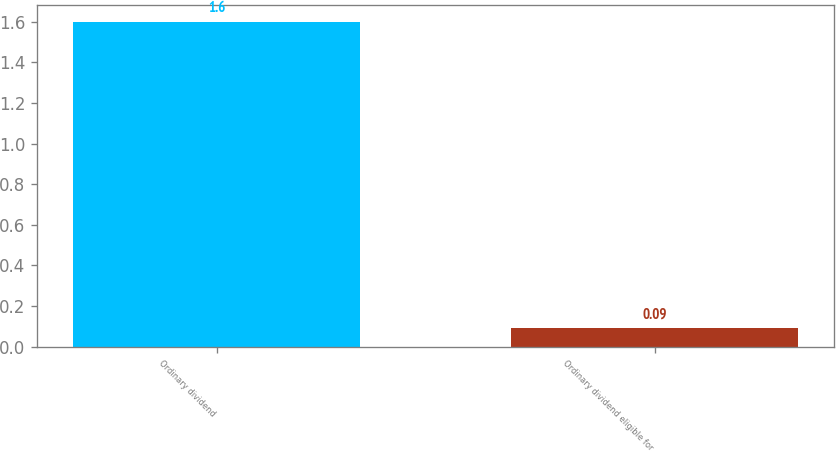<chart> <loc_0><loc_0><loc_500><loc_500><bar_chart><fcel>Ordinary dividend<fcel>Ordinary dividend eligible for<nl><fcel>1.6<fcel>0.09<nl></chart> 